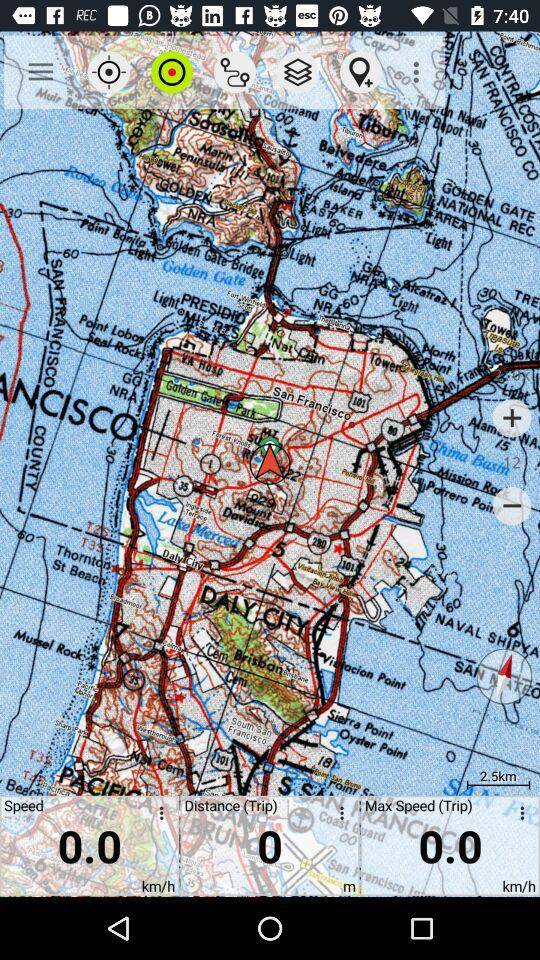How much distance is covered? The distance covered is 0 km. 